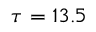<formula> <loc_0><loc_0><loc_500><loc_500>\tau = 1 3 . 5</formula> 